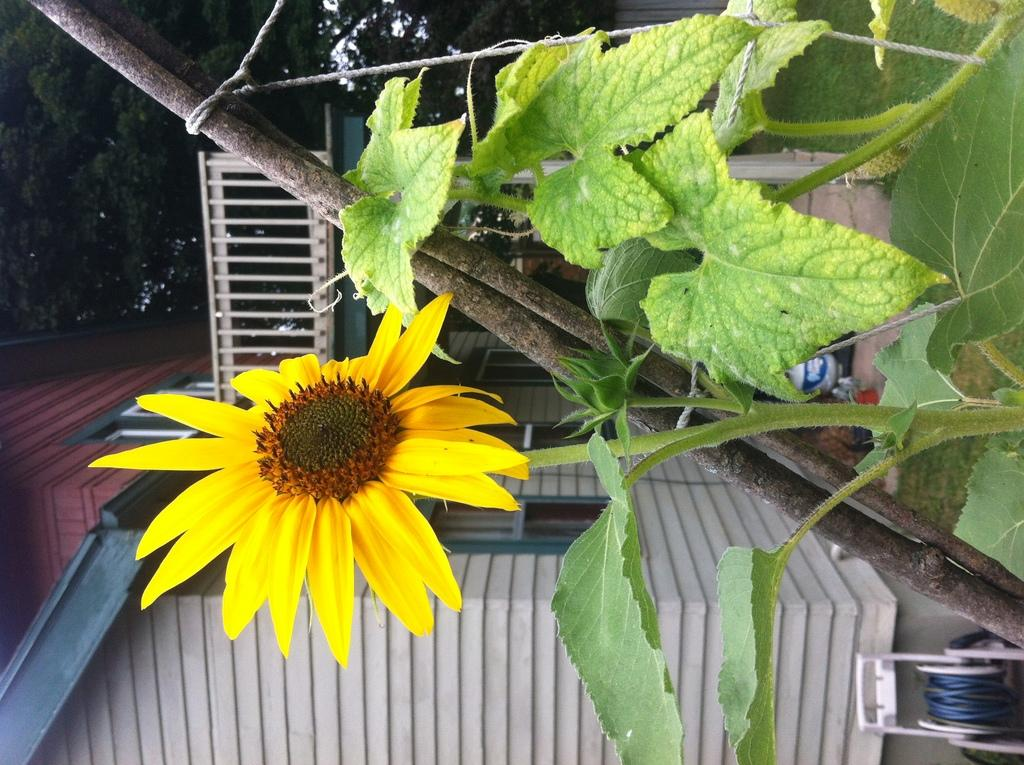What type of living organisms can be seen in the image? Plants and trees are visible in the image. What type of structure is present in the image? There is a building in the image. What part of the natural environment is visible in the image? The sky is visible in the image. What type of peace agreement is being signed in the image? There is no indication of a peace agreement or any signing event in the image. 